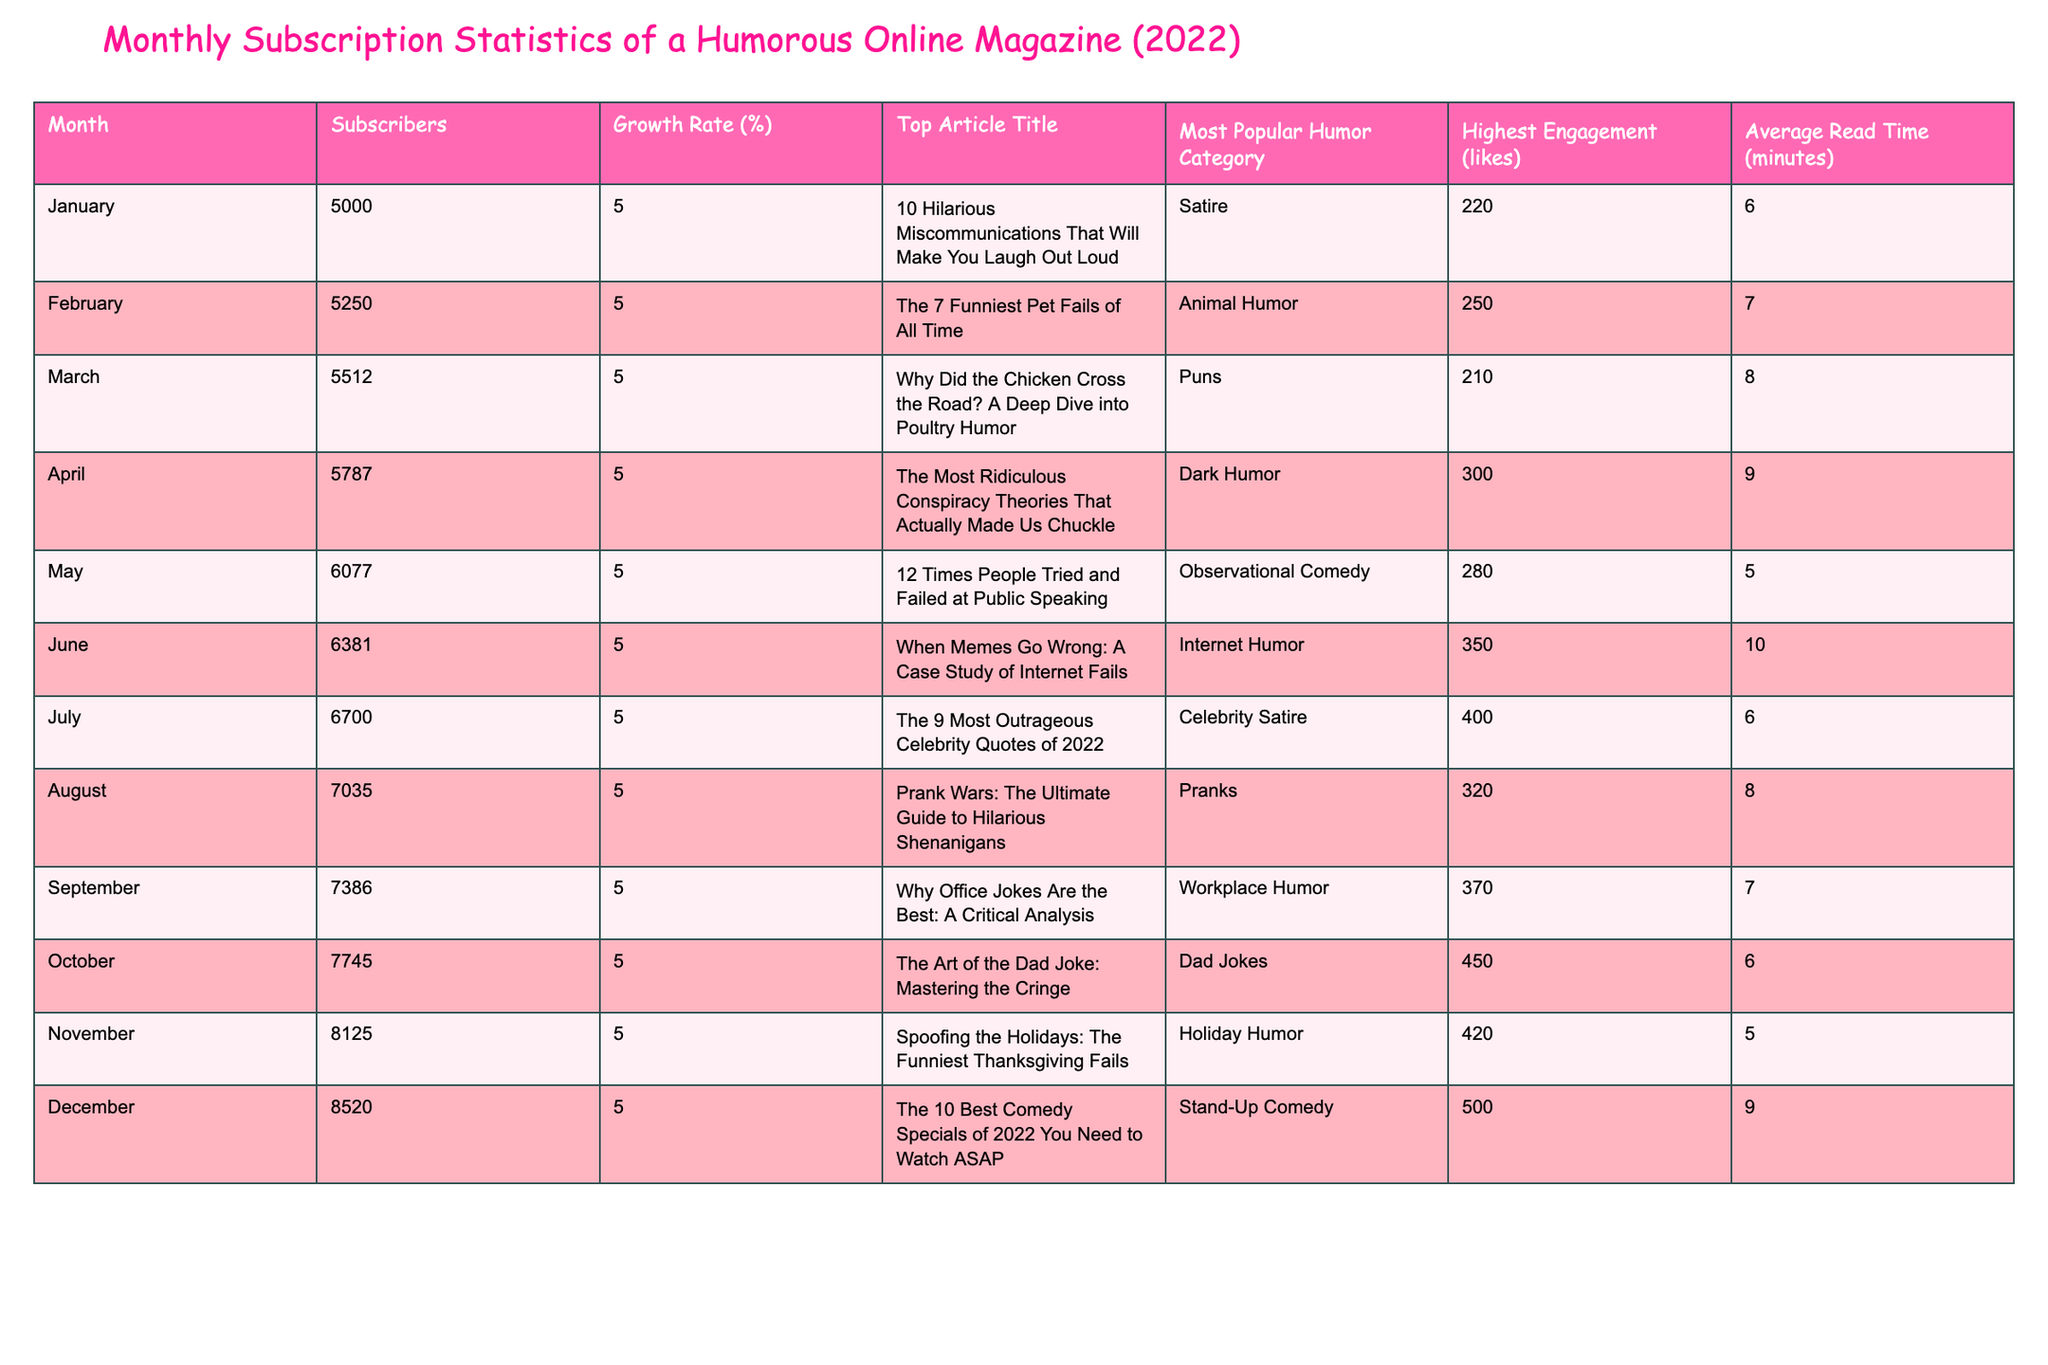What was the highest subscriber count in December 2022? In December, the subscriber count listed in the table is 8,520. This value is specifically stated in the table under the Subscribers column for December.
Answer: 8,520 Which month saw the lowest average read time? The average read time for each month is provided in the respective row. By looking at the data, May shows the lowest average read time of 5 minutes.
Answer: 5 minutes What was the total growth in subscribers from January to December? January had 5,000 subscribers, while December had 8,520. The total growth is calculated as 8,520 - 5,000 = 3,520 subscribers.
Answer: 3,520 Is the most popular humor category in January the same as in April? In January, the most popular humor category is "Satire," whereas in April, it is "Dark Humor." Since these categories are different, the answer is no.
Answer: No What was the average likes across all months? To find the average likes, add all the likes (220 + 250 + 210 + 300 + 280 + 350 + 400 + 320 + 370 + 450 + 420 + 500 = 4,500) and divide by the number of months (12). So, 4,500 / 12 = 375.
Answer: 375 During which month did subscribers grow the most? Every month shows a consistent growth rate of 5%. Therefore, the count of subscribers is simply continuous growth with no standout month for increased rates. The growth is constant each month.
Answer: All months have the same growth rate What was the title of the top article in February? The table explicitly lists the title of the top article for each month. For February, the title is "The 7 Funniest Pet Fails of All Time." This is directly referenced in the table under the Top Article Title column for February.
Answer: "The 7 Funniest Pet Fails of All Time" Which humor category had the highest engagement in December? According to the table, the highest engagement in December is listed as 500 likes and the most popular humor category remains "Stand-Up Comedy." Thus, this is the category with maximum engagement for that month.
Answer: Stand-Up Comedy What is the median value of subscribers throughout 2022? To find the median, we should arrange the subscriber values in order: 5,000; 5,250; 5,512; 5,787; 6,077; 6,381; 6,700; 7,035; 7,386; 7,745; 8,125; 8,520. The median (the average of the two middle numbers) is (6,381 + 6,700) / 2 = 6,540.5.
Answer: 6,540.5 What is the total number of likes across the year? Sum all the likes from each month (220 + 250 + 210 + 300 + 280 + 350 + 400 + 320 + 370 + 450 + 420 + 500 = 4,500). Hence, the total number of likes throughout the year is 4,500.
Answer: 4,500 